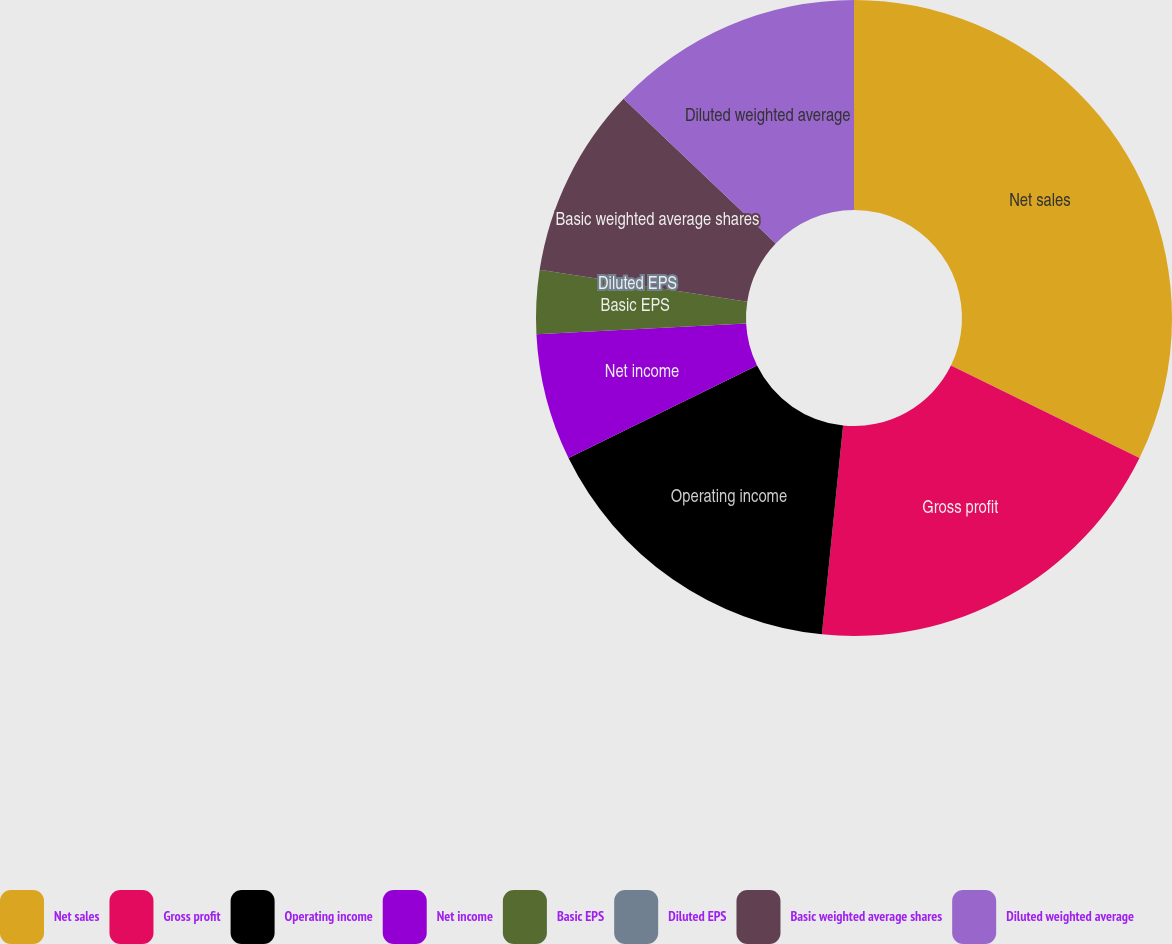<chart> <loc_0><loc_0><loc_500><loc_500><pie_chart><fcel>Net sales<fcel>Gross profit<fcel>Operating income<fcel>Net income<fcel>Basic EPS<fcel>Diluted EPS<fcel>Basic weighted average shares<fcel>Diluted weighted average<nl><fcel>32.26%<fcel>19.35%<fcel>16.13%<fcel>6.45%<fcel>3.23%<fcel>0.0%<fcel>9.68%<fcel>12.9%<nl></chart> 